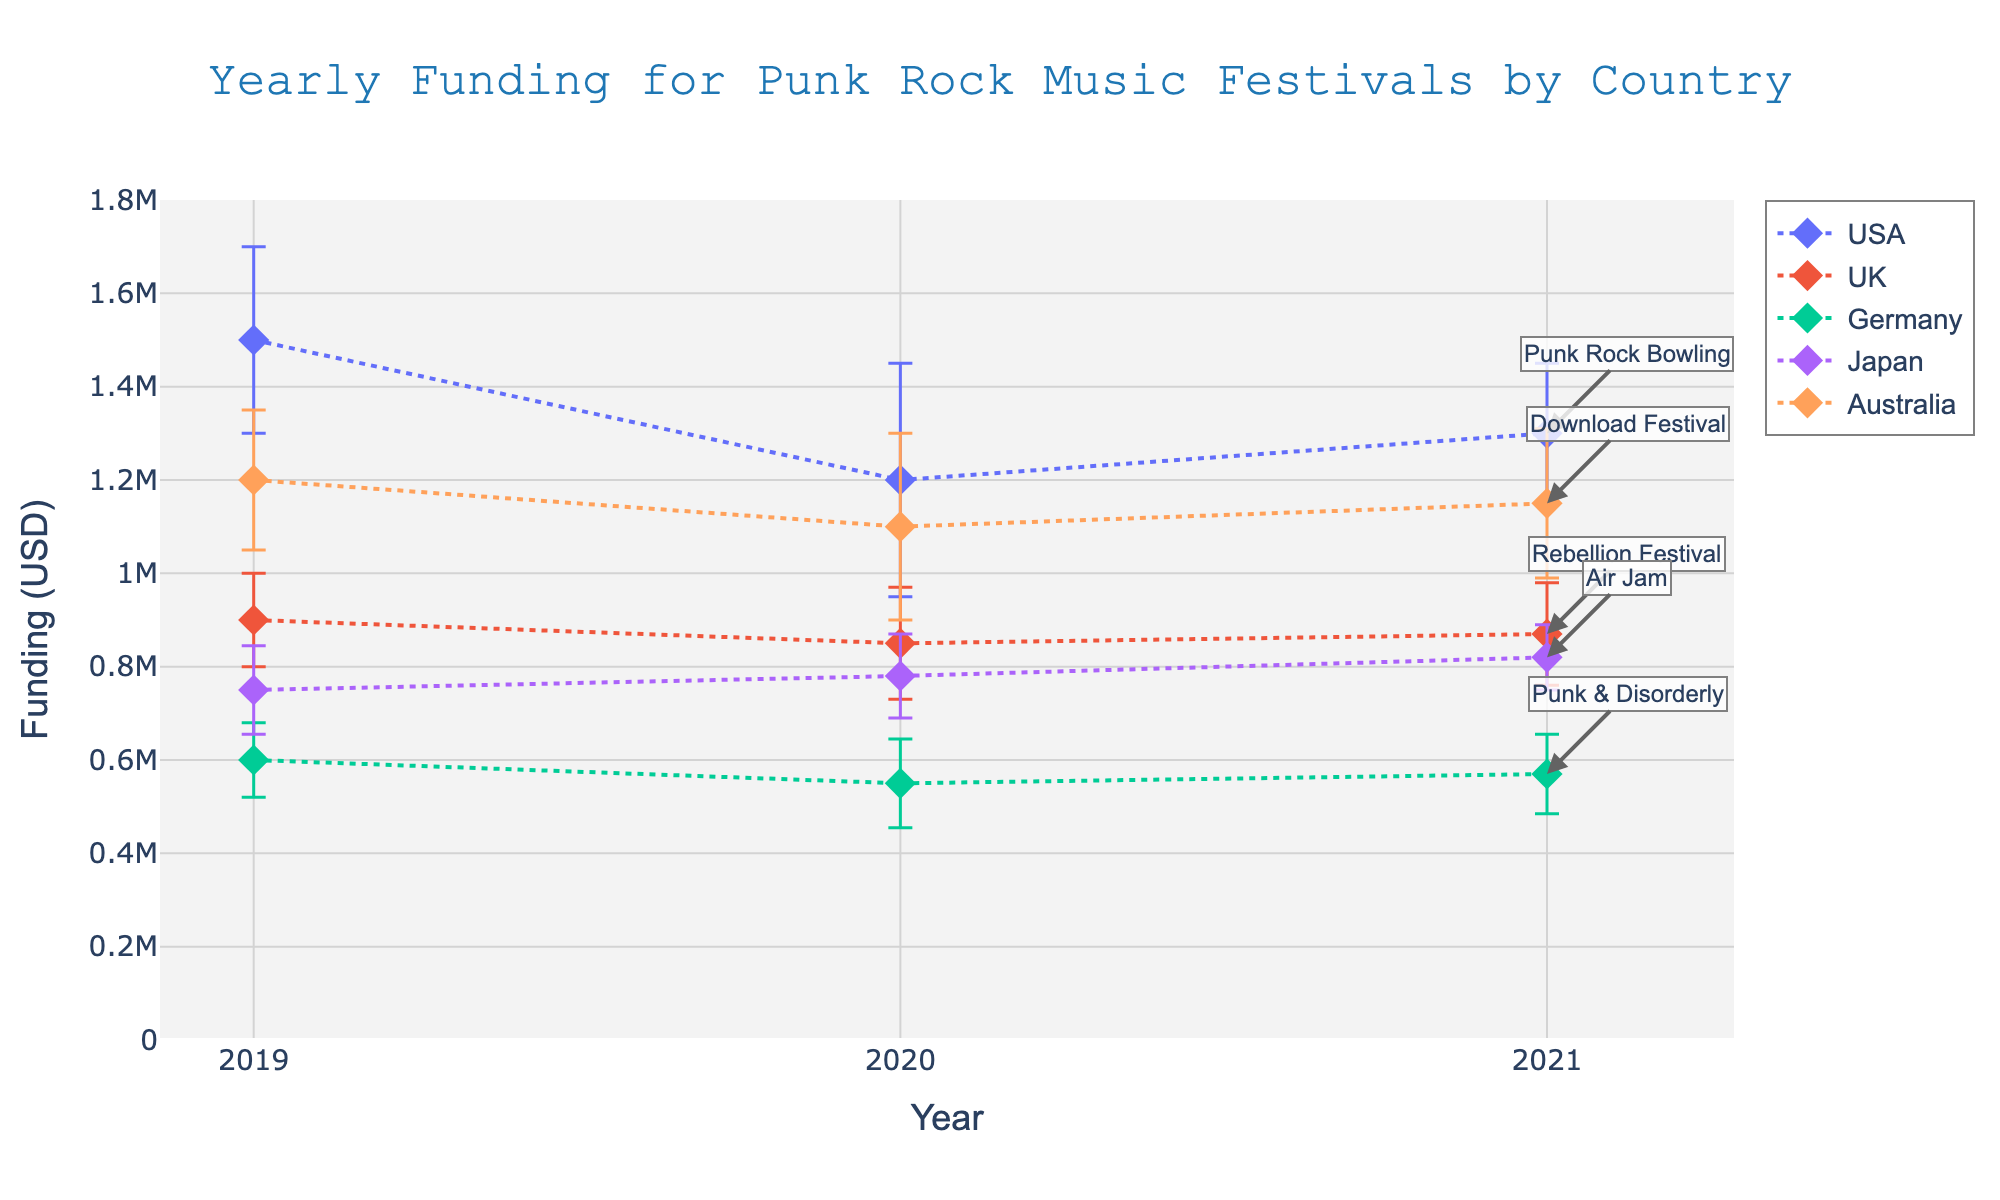What's the title of the plot? The title is located at the top of the plot and is a concise summary of what the plot represents.
Answer: Yearly Funding for Punk Rock Music Festivals by Country How many years are displayed on the x-axis? The x-axis typically indicates the year, and it visually represents different points in time. By counting the different ticks on the x-axis, one can determine the number of years.
Answer: 3 Which country received the highest funding in 2021? By looking at the markers on the plot for the year 2021, one can find the country with the highest y-value, which corresponds to the highest funding.
Answer: USA What is the funding amount for the Rebellion Festival in 2020? First, identify the country (UK) and the respective year (2020). Then, find the corresponding y-value marker on the plot.
Answer: 850000 USD Compare the funding changes for Punk Rock Bowling from 2019 to 2020. Did it increase or decrease? By comparing the y-values for the markers representing the years 2019 and 2020 for Punk Rock Bowling, one can see how the funding changed.
Answer: Decrease What's the average funding for Air Jam over the three years? To find the average, add the funding amounts for Air Jam for 2019, 2020, and 2021, then divide by the number of years.
Answer: (750000 + 780000 + 820000) / 3 = 783333.33 USD Which festival had the smallest error bar in 2021? Error bars represent the uncertainty in the funding data. Find the 2021 markers and observe the shortest vertical error bar visually.
Answer: Air Jam How much did the funding for Download Festival in Australia change from 2020 to 2021? Calculate the difference between the funding amounts for Download Festival between these two years.
Answer: 1150000 - 1100000 = 50000 USD Between Punk & Disorderly and Rebellion Festival, which had a higher funding in 2019? Identify the funding amounts for both festivals in 2019 and compare their y-values to determine which is higher.
Answer: Rebellion Festival What trend is observed in funding for Punk & Disorderly from 2019 to 2021? Observe the direction of the funding markers for Punk & Disorderly over the years to understand if the trend is increasing, decreasing, or stable.
Answer: Decreasing then slight increase 